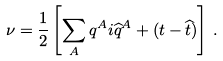Convert formula to latex. <formula><loc_0><loc_0><loc_500><loc_500>\nu = \frac { 1 } { 2 } \left [ \sum _ { A } q ^ { A } i \widehat { q } ^ { A } + ( t - \widehat { t } ) \right ] \, .</formula> 